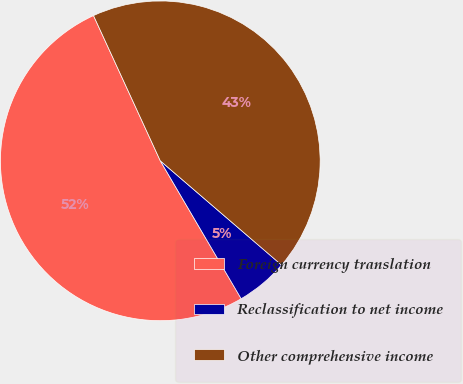Convert chart. <chart><loc_0><loc_0><loc_500><loc_500><pie_chart><fcel>Foreign currency translation<fcel>Reclassification to net income<fcel>Other comprehensive income<nl><fcel>51.58%<fcel>5.26%<fcel>43.16%<nl></chart> 